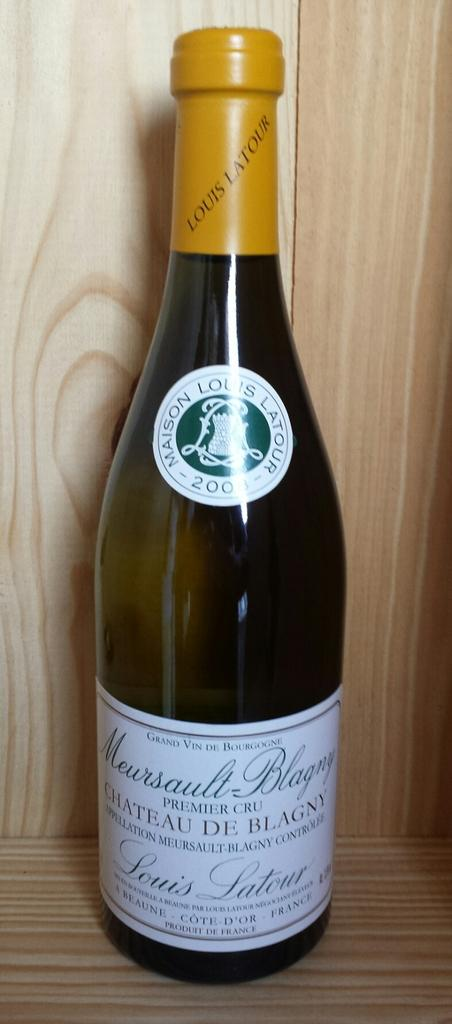<image>
Share a concise interpretation of the image provided. A bottle of Maison Louis Latour champagne sits on a shelf. 